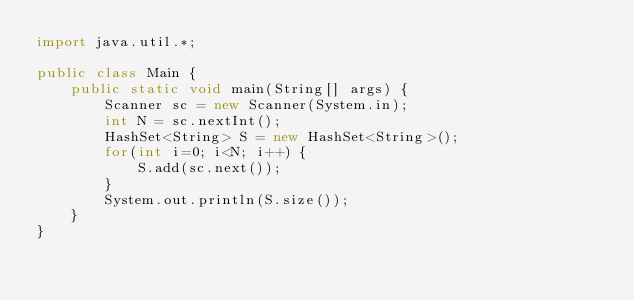Convert code to text. <code><loc_0><loc_0><loc_500><loc_500><_Java_>import java.util.*;

public class Main {
	public static void main(String[] args) {
    	Scanner sc = new Scanner(System.in);
        int N = sc.nextInt();
		HashSet<String> S = new HashSet<String>();
        for(int i=0; i<N; i++) {
        	S.add(sc.next());
        }
        System.out.println(S.size());
    }
}</code> 